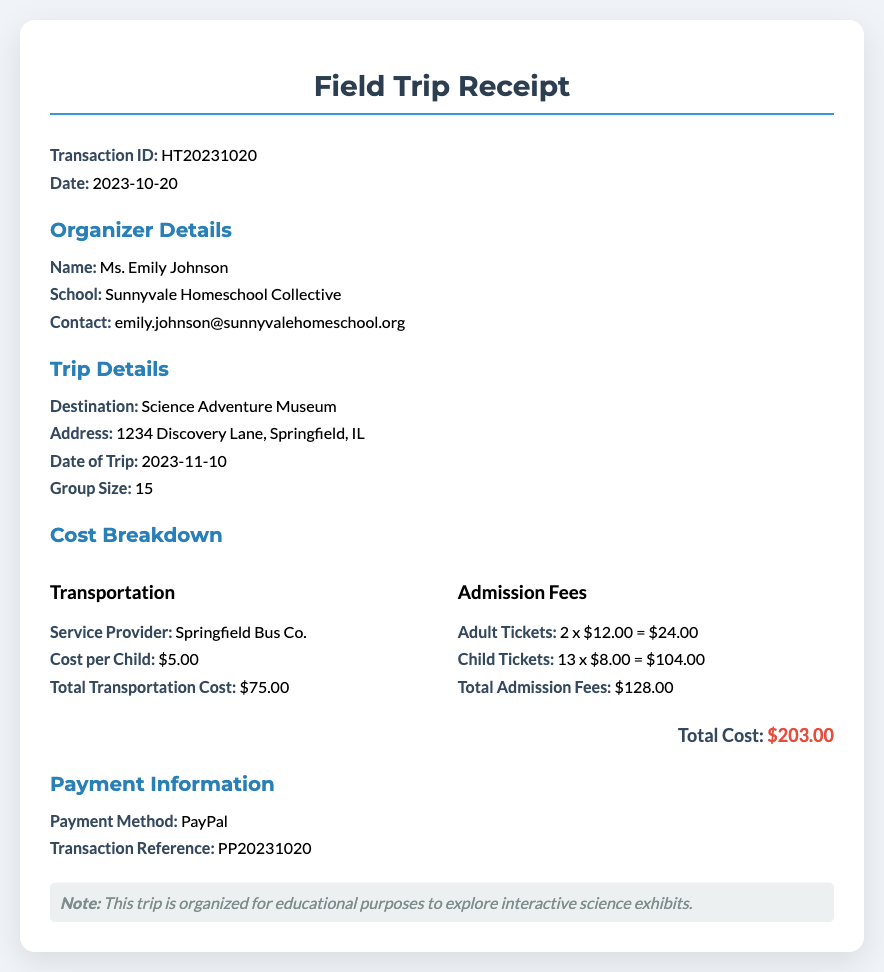What is the transaction ID? The transaction ID is a unique identifier for this receipt which is HT20231020.
Answer: HT20231020 Who is the organizer of the trip? The organizer's name is listed in the document, which is Ms. Emily Johnson.
Answer: Ms. Emily Johnson What is the total cost of the trip? The total cost is stated at the end of the cost breakdown, which combines all expenses, $203.00.
Answer: $203.00 What is the cost per child for transportation? The cost per child is specified in the transportation section of the receipt, which is $5.00.
Answer: $5.00 How many children attended the trip? The number of children is indicated in the group size section as part of the trip details, which is 13.
Answer: 13 What payment method was used? The payment method is detailed in the payment information section, which shows PayPal.
Answer: PayPal What is the address of the destination? The address is provided in the trip details section, which is 1234 Discovery Lane, Springfield, IL.
Answer: 1234 Discovery Lane, Springfield, IL How many adult tickets were purchased? The number of adult tickets purchased is calculated from the admission fees section, where it mentions 2 adult tickets.
Answer: 2 What date is the field trip scheduled for? The date of the trip is specified in the trip details section as 2023-11-10.
Answer: 2023-11-10 